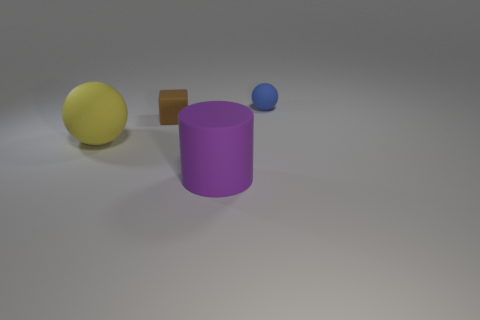Subtract all blue spheres. How many spheres are left? 1 Subtract all cylinders. How many objects are left? 3 Subtract all gray cylinders. How many yellow spheres are left? 1 Subtract all brown spheres. Subtract all brown cylinders. How many spheres are left? 2 Add 1 brown metallic things. How many brown metallic things exist? 1 Add 4 yellow rubber things. How many objects exist? 8 Subtract 0 cyan balls. How many objects are left? 4 Subtract all blue things. Subtract all large yellow rubber balls. How many objects are left? 2 Add 2 blue objects. How many blue objects are left? 3 